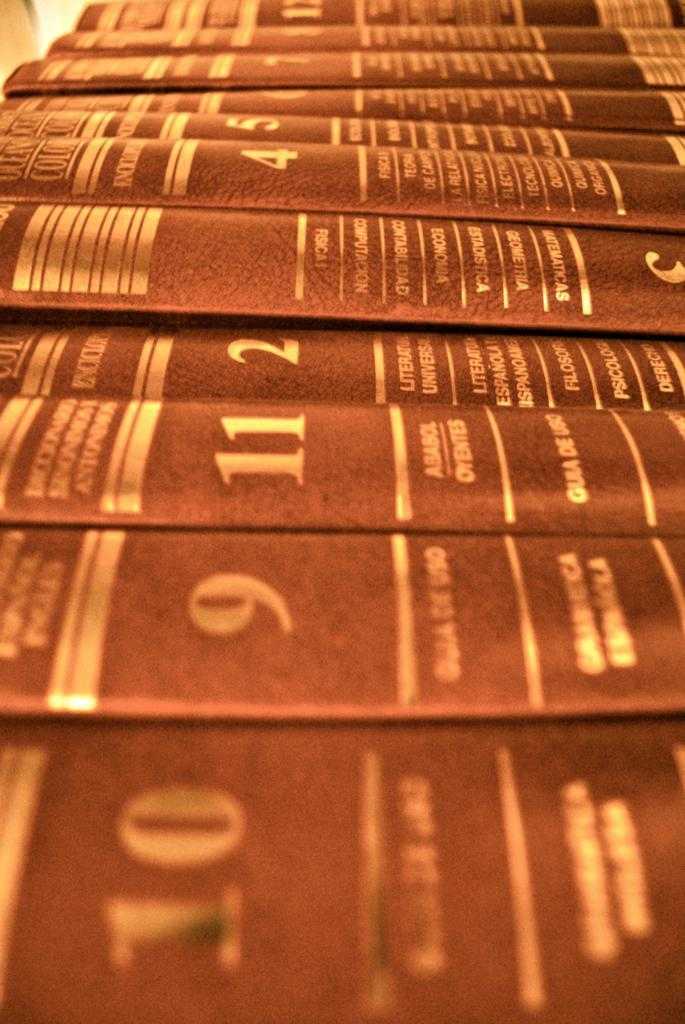<image>
Summarize the visual content of the image. A collection of books shows that they are numbered up to at least 11 but are not organized in order. 